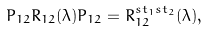<formula> <loc_0><loc_0><loc_500><loc_500>P _ { 1 2 } R _ { 1 2 } ( \lambda ) P _ { 1 2 } = R ^ { s t _ { 1 } s t _ { 2 } } _ { 1 2 } ( \lambda ) ,</formula> 